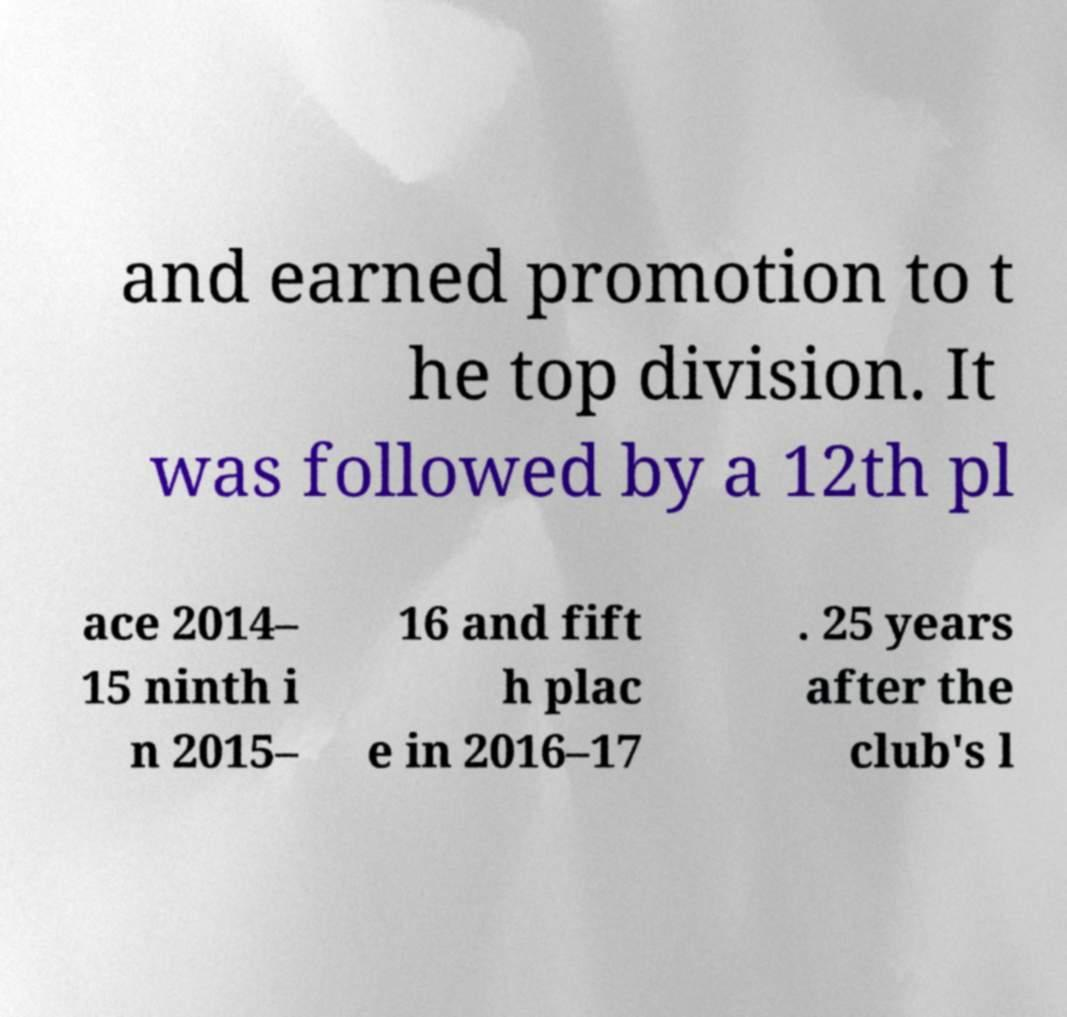I need the written content from this picture converted into text. Can you do that? and earned promotion to t he top division. It was followed by a 12th pl ace 2014– 15 ninth i n 2015– 16 and fift h plac e in 2016–17 . 25 years after the club's l 